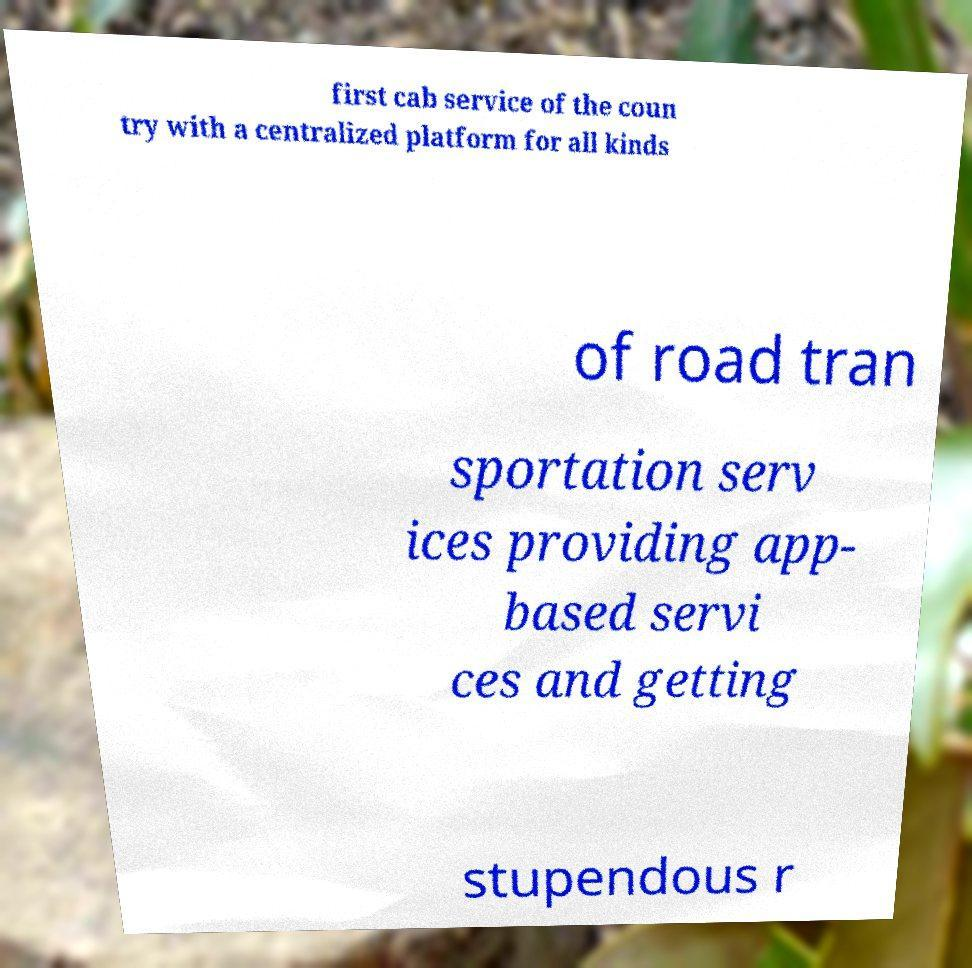Can you accurately transcribe the text from the provided image for me? first cab service of the coun try with a centralized platform for all kinds of road tran sportation serv ices providing app- based servi ces and getting stupendous r 